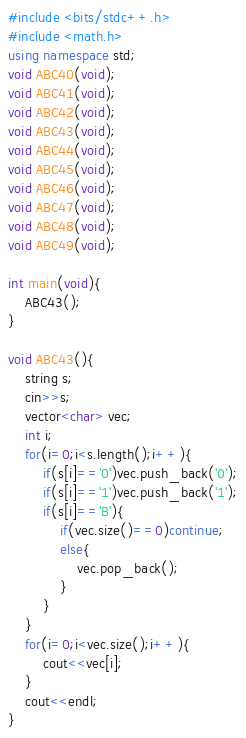<code> <loc_0><loc_0><loc_500><loc_500><_C++_>#include <bits/stdc++.h>
#include <math.h>
using namespace std;
void ABC40(void);
void ABC41(void);
void ABC42(void);
void ABC43(void);
void ABC44(void);
void ABC45(void);
void ABC46(void);
void ABC47(void);
void ABC48(void);
void ABC49(void);

int main(void){
    ABC43();
}

void ABC43(){
    string s;
    cin>>s;
    vector<char> vec;
    int i;
    for(i=0;i<s.length();i++){
        if(s[i]=='0')vec.push_back('0');
        if(s[i]=='1')vec.push_back('1');
        if(s[i]=='B'){
            if(vec.size()==0)continue;
            else{
                vec.pop_back();
            }
        }
    }
    for(i=0;i<vec.size();i++){
        cout<<vec[i];
    }
    cout<<endl;
}</code> 